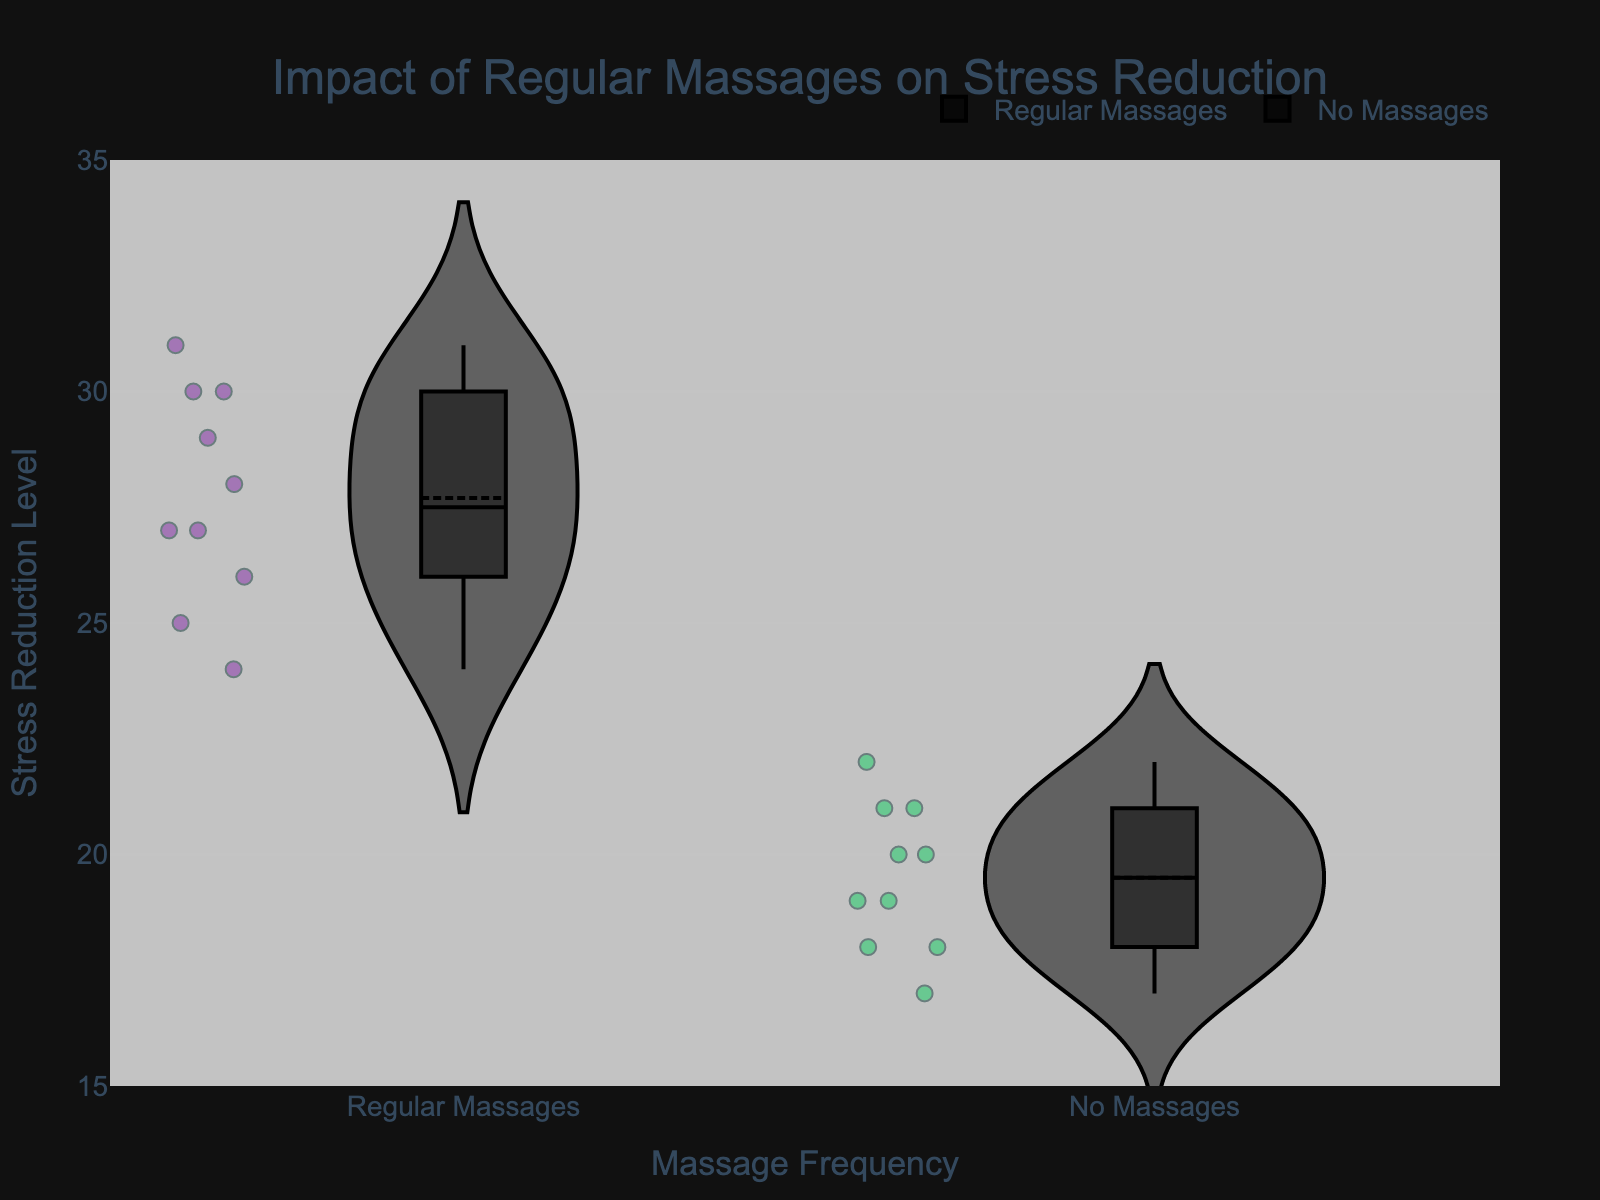What is the title of the figure? The title of the figure is located at the top and it summarizes the main point of the plot. The title reads "Impact of Regular Massages on Stress Reduction".
Answer: Impact of Regular Massages on Stress Reduction What does the x-axis represent? The x-axis labels indicate the groups being compared in the figure. The labels show "Regular Massages" and "No Massages".
Answer: Massage Frequency How many data points are there for the "No Massages" group? All of the data points are visible as individual dots in the violin plot for the "No Massages" group. Counting these points gives a total of 10.
Answer: 10 What color represents the group receiving "Regular Massages"? The color in the plot legend indicates which color represents each group. The "Regular Massages" group is represented by a purple color.
Answer: Purple Which group has the higher median stress reduction level? The box within each violin plot represents the median. By comparing the central lines of the boxes, the group receiving "Regular Massages" clearly has a higher median line than the "No Massages" group.
Answer: Regular Massages What are the stress reduction levels for the "No Massages" group with the lowest and highest values? The dots representing individual data points show the spread of values. For the "No Massages" group, the lowest value is 17, and the highest value is 22.
Answer: 17 and 22 What range does the "Regular Massages" group cover? The violin plot shows the distribution spread along the y-axis. For "Regular Massages," the data ranges from 24 to 31.
Answer: 24 to 31 Which group shows a wider range of stress reduction levels? By observing the extent of the violin spread and the range of data points, "Regular Massages" shows a wider range (24 to 31) compared to "No Massages" (17 to 22). This indicates a broader variability in stress reduction levels.
Answer: Regular Massages How does the mean of the "Regular Massages" group compare to the "No Massages" group? The mean, indicated by a marker line in the viola plot, is visually higher for the "Regular Massages" group compared to the "No Massages" group. This is determined by the location of the mean marker on the y-axis.
Answer: Higher What do the box plots within the violins represent? Each violin plot contains a box plot, which gives additional information. The box plot shows the median value as a central line, and the interquartile range (IQR) represented by the box's upper and lower limits.
Answer: Median and IQR 